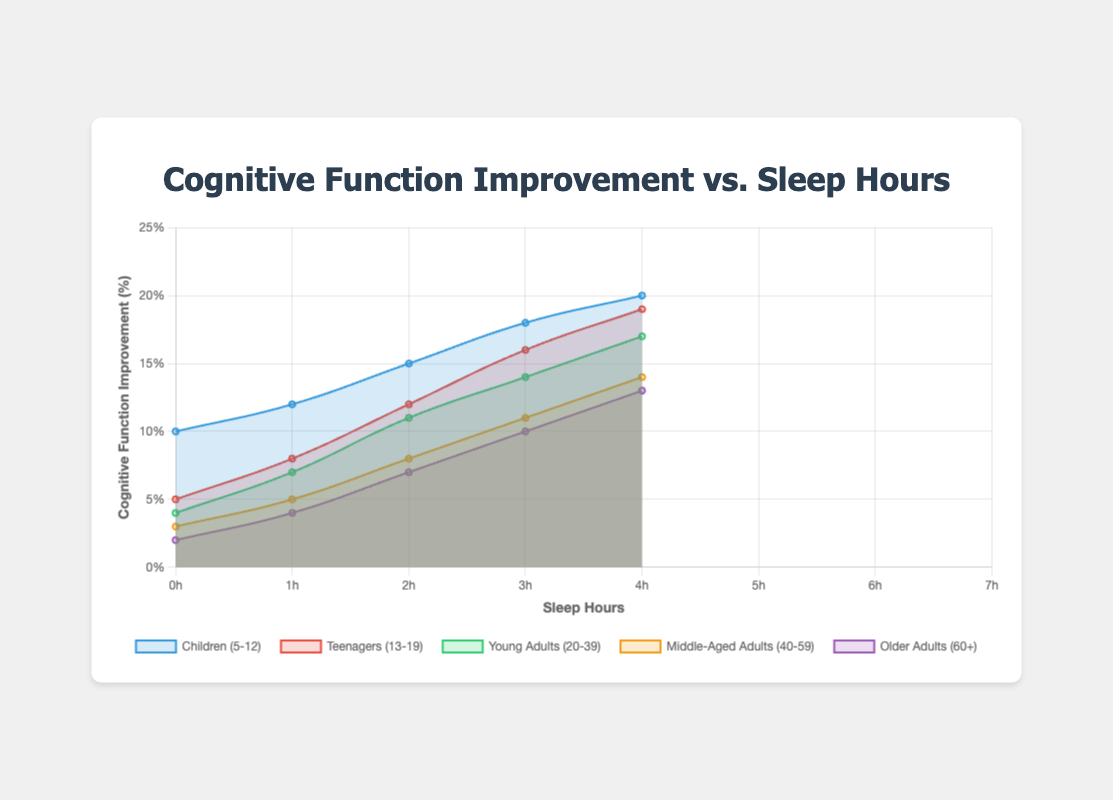What is the cognitive function improvement percentage for "Teens (13-19)" sleeping 8 hours? First, locate the line associated with "Teens (13-19)", which can be identified by its label or color. Follow this line to the point corresponding to 8 hours of sleep, then read the y-axis value for cognitive function improvement percentage.
Answer: 12% Which age group shows the highest cognitive function improvement percentage with 9 hours of sleep? Look for the points at 9 hours of sleep across all age group lines. Compare these points to see which one sits highest on the y-axis, representing the percentage. "Children (5-12)" has the highest point at 20%.
Answer: Children (5-12) Which age group has the smallest improvement percentage for any given amount of sleep? Compare the lowest points of each line by looking at their positions along the y-axis. Identify the point closest to the x-axis. It's "Older Adults (60+)" with 2% at 5 hours of sleep.
Answer: Older Adults (60+) What is the total cognitive function improvement for "Middle-Aged Adults (40-59)" when adding up all percentages from 5 to 9 hours of sleep? Add the cognitive function improvement percentages for "Middle-Aged Adults (40-59)": \(3 + 5 + 8 + 11 + 14\). Sum these values: \(3 + 5 = 8\), \(8 + 8 = 16\), \(16 + 11 = 27\), \(27 + 14 = 41\).
Answer: 41% Between "Teens (13-19)" and "Young Adults (20-39)", which group improves more significantly from 6 to 8 hours of sleep? Calculate the improvement for each group from 6 to 8 hours. For "Teens (13-19)", it's \(12 - 5 = 7\). For "Young Adults (20-39)", it's \(11 - 4 = 7\). Both groups improve by 7%.
Answer: Both groups improve by 7% What is the average cognitive function improvement for "Young Adults (20-39)" at 6, 7, and 8 hours of sleep? Find the improvement percentages for "Young Adults (20-39)" at 6, 7, and 8 hours: (4, 7, 11). Calculate the average: \((4 + 7 + 11) / 3 = 22 / 3\). Simplify the result to get approximately \(7.33\).
Answer: 7.33% If the sleep hours increase by 1 hour, what is the average increase in cognitive function improvement percentage for "Children (5-12)"? Determine the percentage differences between each consecutive hour of sleep for "Children (5-12)": \((12 - 10), (15 - 12), (18 - 15), (20 - 18)\). Calculate average increase: \((2 + 3 + 3 + 2) / 4 = 10 / 4\). The average increase is 2.5%.
Answer: 2.5% At what sleep hour does "Older Adults (60+)" reach a cognitive function improvement percentage of 10%? Follow the line indicating "Older Adults (60+)" and look for the point where the cognitive function improvement percentage reaches 10%. This occurs at 8 hours of sleep.
Answer: 8 hours 